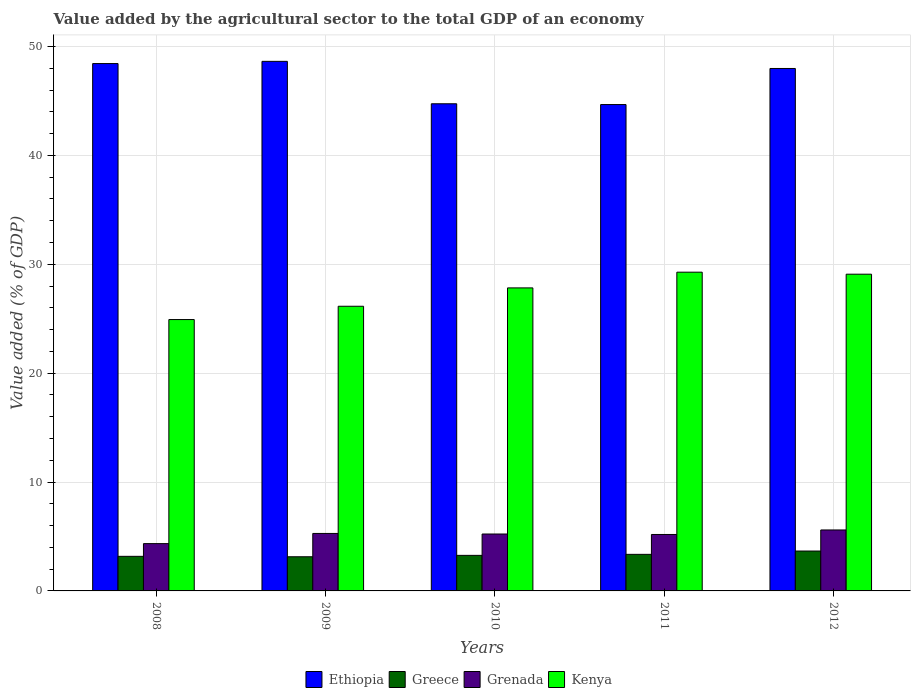How many bars are there on the 3rd tick from the left?
Provide a short and direct response. 4. How many bars are there on the 2nd tick from the right?
Keep it short and to the point. 4. What is the value added by the agricultural sector to the total GDP in Grenada in 2010?
Offer a terse response. 5.23. Across all years, what is the maximum value added by the agricultural sector to the total GDP in Greece?
Your answer should be compact. 3.66. Across all years, what is the minimum value added by the agricultural sector to the total GDP in Grenada?
Provide a succinct answer. 4.34. What is the total value added by the agricultural sector to the total GDP in Grenada in the graph?
Offer a very short reply. 25.63. What is the difference between the value added by the agricultural sector to the total GDP in Greece in 2008 and that in 2010?
Offer a terse response. -0.09. What is the difference between the value added by the agricultural sector to the total GDP in Ethiopia in 2008 and the value added by the agricultural sector to the total GDP in Kenya in 2012?
Your answer should be very brief. 19.34. What is the average value added by the agricultural sector to the total GDP in Kenya per year?
Provide a succinct answer. 27.45. In the year 2011, what is the difference between the value added by the agricultural sector to the total GDP in Grenada and value added by the agricultural sector to the total GDP in Kenya?
Ensure brevity in your answer.  -24.09. What is the ratio of the value added by the agricultural sector to the total GDP in Grenada in 2010 to that in 2011?
Offer a terse response. 1.01. Is the value added by the agricultural sector to the total GDP in Ethiopia in 2009 less than that in 2011?
Give a very brief answer. No. Is the difference between the value added by the agricultural sector to the total GDP in Grenada in 2009 and 2012 greater than the difference between the value added by the agricultural sector to the total GDP in Kenya in 2009 and 2012?
Keep it short and to the point. Yes. What is the difference between the highest and the second highest value added by the agricultural sector to the total GDP in Kenya?
Offer a very short reply. 0.18. What is the difference between the highest and the lowest value added by the agricultural sector to the total GDP in Ethiopia?
Make the answer very short. 3.97. Is the sum of the value added by the agricultural sector to the total GDP in Kenya in 2011 and 2012 greater than the maximum value added by the agricultural sector to the total GDP in Greece across all years?
Keep it short and to the point. Yes. What does the 1st bar from the left in 2012 represents?
Provide a succinct answer. Ethiopia. What does the 3rd bar from the right in 2012 represents?
Make the answer very short. Greece. Is it the case that in every year, the sum of the value added by the agricultural sector to the total GDP in Grenada and value added by the agricultural sector to the total GDP in Greece is greater than the value added by the agricultural sector to the total GDP in Ethiopia?
Give a very brief answer. No. What is the difference between two consecutive major ticks on the Y-axis?
Provide a succinct answer. 10. Are the values on the major ticks of Y-axis written in scientific E-notation?
Provide a succinct answer. No. Does the graph contain any zero values?
Offer a terse response. No. Where does the legend appear in the graph?
Your answer should be compact. Bottom center. How many legend labels are there?
Keep it short and to the point. 4. How are the legend labels stacked?
Provide a succinct answer. Horizontal. What is the title of the graph?
Offer a terse response. Value added by the agricultural sector to the total GDP of an economy. Does "Gabon" appear as one of the legend labels in the graph?
Provide a short and direct response. No. What is the label or title of the Y-axis?
Your answer should be very brief. Value added (% of GDP). What is the Value added (% of GDP) in Ethiopia in 2008?
Provide a succinct answer. 48.43. What is the Value added (% of GDP) in Greece in 2008?
Provide a succinct answer. 3.18. What is the Value added (% of GDP) of Grenada in 2008?
Make the answer very short. 4.34. What is the Value added (% of GDP) in Kenya in 2008?
Offer a very short reply. 24.92. What is the Value added (% of GDP) of Ethiopia in 2009?
Provide a short and direct response. 48.64. What is the Value added (% of GDP) in Greece in 2009?
Make the answer very short. 3.14. What is the Value added (% of GDP) of Grenada in 2009?
Provide a short and direct response. 5.28. What is the Value added (% of GDP) in Kenya in 2009?
Your answer should be very brief. 26.14. What is the Value added (% of GDP) of Ethiopia in 2010?
Your answer should be compact. 44.74. What is the Value added (% of GDP) in Greece in 2010?
Your answer should be very brief. 3.27. What is the Value added (% of GDP) of Grenada in 2010?
Offer a very short reply. 5.23. What is the Value added (% of GDP) in Kenya in 2010?
Your answer should be compact. 27.83. What is the Value added (% of GDP) of Ethiopia in 2011?
Your response must be concise. 44.67. What is the Value added (% of GDP) in Greece in 2011?
Offer a very short reply. 3.36. What is the Value added (% of GDP) in Grenada in 2011?
Make the answer very short. 5.18. What is the Value added (% of GDP) of Kenya in 2011?
Offer a very short reply. 29.27. What is the Value added (% of GDP) in Ethiopia in 2012?
Your response must be concise. 47.98. What is the Value added (% of GDP) in Greece in 2012?
Give a very brief answer. 3.66. What is the Value added (% of GDP) of Grenada in 2012?
Provide a succinct answer. 5.6. What is the Value added (% of GDP) in Kenya in 2012?
Your answer should be compact. 29.09. Across all years, what is the maximum Value added (% of GDP) in Ethiopia?
Make the answer very short. 48.64. Across all years, what is the maximum Value added (% of GDP) in Greece?
Give a very brief answer. 3.66. Across all years, what is the maximum Value added (% of GDP) of Grenada?
Offer a very short reply. 5.6. Across all years, what is the maximum Value added (% of GDP) of Kenya?
Provide a short and direct response. 29.27. Across all years, what is the minimum Value added (% of GDP) of Ethiopia?
Your answer should be compact. 44.67. Across all years, what is the minimum Value added (% of GDP) of Greece?
Keep it short and to the point. 3.14. Across all years, what is the minimum Value added (% of GDP) of Grenada?
Make the answer very short. 4.34. Across all years, what is the minimum Value added (% of GDP) of Kenya?
Your answer should be compact. 24.92. What is the total Value added (% of GDP) in Ethiopia in the graph?
Your answer should be compact. 234.46. What is the total Value added (% of GDP) in Greece in the graph?
Your answer should be very brief. 16.6. What is the total Value added (% of GDP) of Grenada in the graph?
Provide a succinct answer. 25.63. What is the total Value added (% of GDP) of Kenya in the graph?
Make the answer very short. 137.26. What is the difference between the Value added (% of GDP) of Ethiopia in 2008 and that in 2009?
Your response must be concise. -0.2. What is the difference between the Value added (% of GDP) in Greece in 2008 and that in 2009?
Your answer should be very brief. 0.04. What is the difference between the Value added (% of GDP) in Grenada in 2008 and that in 2009?
Your response must be concise. -0.94. What is the difference between the Value added (% of GDP) of Kenya in 2008 and that in 2009?
Make the answer very short. -1.22. What is the difference between the Value added (% of GDP) in Ethiopia in 2008 and that in 2010?
Ensure brevity in your answer.  3.69. What is the difference between the Value added (% of GDP) of Greece in 2008 and that in 2010?
Make the answer very short. -0.09. What is the difference between the Value added (% of GDP) of Grenada in 2008 and that in 2010?
Make the answer very short. -0.88. What is the difference between the Value added (% of GDP) of Kenya in 2008 and that in 2010?
Provide a short and direct response. -2.91. What is the difference between the Value added (% of GDP) in Ethiopia in 2008 and that in 2011?
Offer a terse response. 3.76. What is the difference between the Value added (% of GDP) in Greece in 2008 and that in 2011?
Your answer should be very brief. -0.18. What is the difference between the Value added (% of GDP) in Grenada in 2008 and that in 2011?
Provide a short and direct response. -0.84. What is the difference between the Value added (% of GDP) of Kenya in 2008 and that in 2011?
Provide a succinct answer. -4.35. What is the difference between the Value added (% of GDP) in Ethiopia in 2008 and that in 2012?
Provide a succinct answer. 0.45. What is the difference between the Value added (% of GDP) of Greece in 2008 and that in 2012?
Give a very brief answer. -0.49. What is the difference between the Value added (% of GDP) of Grenada in 2008 and that in 2012?
Provide a short and direct response. -1.25. What is the difference between the Value added (% of GDP) in Kenya in 2008 and that in 2012?
Your answer should be very brief. -4.17. What is the difference between the Value added (% of GDP) of Ethiopia in 2009 and that in 2010?
Offer a very short reply. 3.9. What is the difference between the Value added (% of GDP) in Greece in 2009 and that in 2010?
Make the answer very short. -0.13. What is the difference between the Value added (% of GDP) of Grenada in 2009 and that in 2010?
Provide a succinct answer. 0.05. What is the difference between the Value added (% of GDP) of Kenya in 2009 and that in 2010?
Offer a very short reply. -1.69. What is the difference between the Value added (% of GDP) of Ethiopia in 2009 and that in 2011?
Your response must be concise. 3.97. What is the difference between the Value added (% of GDP) in Greece in 2009 and that in 2011?
Make the answer very short. -0.22. What is the difference between the Value added (% of GDP) in Grenada in 2009 and that in 2011?
Ensure brevity in your answer.  0.1. What is the difference between the Value added (% of GDP) in Kenya in 2009 and that in 2011?
Make the answer very short. -3.13. What is the difference between the Value added (% of GDP) in Ethiopia in 2009 and that in 2012?
Your response must be concise. 0.65. What is the difference between the Value added (% of GDP) of Greece in 2009 and that in 2012?
Your response must be concise. -0.53. What is the difference between the Value added (% of GDP) in Grenada in 2009 and that in 2012?
Your answer should be very brief. -0.32. What is the difference between the Value added (% of GDP) in Kenya in 2009 and that in 2012?
Your answer should be compact. -2.95. What is the difference between the Value added (% of GDP) of Ethiopia in 2010 and that in 2011?
Provide a short and direct response. 0.07. What is the difference between the Value added (% of GDP) in Greece in 2010 and that in 2011?
Offer a terse response. -0.09. What is the difference between the Value added (% of GDP) of Grenada in 2010 and that in 2011?
Offer a very short reply. 0.04. What is the difference between the Value added (% of GDP) of Kenya in 2010 and that in 2011?
Ensure brevity in your answer.  -1.44. What is the difference between the Value added (% of GDP) of Ethiopia in 2010 and that in 2012?
Offer a very short reply. -3.24. What is the difference between the Value added (% of GDP) in Greece in 2010 and that in 2012?
Offer a terse response. -0.4. What is the difference between the Value added (% of GDP) of Grenada in 2010 and that in 2012?
Provide a succinct answer. -0.37. What is the difference between the Value added (% of GDP) in Kenya in 2010 and that in 2012?
Provide a succinct answer. -1.26. What is the difference between the Value added (% of GDP) in Ethiopia in 2011 and that in 2012?
Your response must be concise. -3.31. What is the difference between the Value added (% of GDP) of Greece in 2011 and that in 2012?
Provide a succinct answer. -0.31. What is the difference between the Value added (% of GDP) of Grenada in 2011 and that in 2012?
Your answer should be very brief. -0.42. What is the difference between the Value added (% of GDP) in Kenya in 2011 and that in 2012?
Your answer should be compact. 0.18. What is the difference between the Value added (% of GDP) in Ethiopia in 2008 and the Value added (% of GDP) in Greece in 2009?
Keep it short and to the point. 45.3. What is the difference between the Value added (% of GDP) in Ethiopia in 2008 and the Value added (% of GDP) in Grenada in 2009?
Offer a terse response. 43.15. What is the difference between the Value added (% of GDP) in Ethiopia in 2008 and the Value added (% of GDP) in Kenya in 2009?
Provide a short and direct response. 22.29. What is the difference between the Value added (% of GDP) of Greece in 2008 and the Value added (% of GDP) of Grenada in 2009?
Your answer should be very brief. -2.1. What is the difference between the Value added (% of GDP) in Greece in 2008 and the Value added (% of GDP) in Kenya in 2009?
Offer a very short reply. -22.97. What is the difference between the Value added (% of GDP) of Grenada in 2008 and the Value added (% of GDP) of Kenya in 2009?
Give a very brief answer. -21.8. What is the difference between the Value added (% of GDP) of Ethiopia in 2008 and the Value added (% of GDP) of Greece in 2010?
Offer a very short reply. 45.17. What is the difference between the Value added (% of GDP) of Ethiopia in 2008 and the Value added (% of GDP) of Grenada in 2010?
Make the answer very short. 43.21. What is the difference between the Value added (% of GDP) of Ethiopia in 2008 and the Value added (% of GDP) of Kenya in 2010?
Offer a very short reply. 20.6. What is the difference between the Value added (% of GDP) of Greece in 2008 and the Value added (% of GDP) of Grenada in 2010?
Offer a very short reply. -2.05. What is the difference between the Value added (% of GDP) in Greece in 2008 and the Value added (% of GDP) in Kenya in 2010?
Make the answer very short. -24.65. What is the difference between the Value added (% of GDP) of Grenada in 2008 and the Value added (% of GDP) of Kenya in 2010?
Your response must be concise. -23.49. What is the difference between the Value added (% of GDP) in Ethiopia in 2008 and the Value added (% of GDP) in Greece in 2011?
Provide a succinct answer. 45.08. What is the difference between the Value added (% of GDP) in Ethiopia in 2008 and the Value added (% of GDP) in Grenada in 2011?
Keep it short and to the point. 43.25. What is the difference between the Value added (% of GDP) in Ethiopia in 2008 and the Value added (% of GDP) in Kenya in 2011?
Give a very brief answer. 19.16. What is the difference between the Value added (% of GDP) of Greece in 2008 and the Value added (% of GDP) of Grenada in 2011?
Your answer should be compact. -2.01. What is the difference between the Value added (% of GDP) of Greece in 2008 and the Value added (% of GDP) of Kenya in 2011?
Give a very brief answer. -26.1. What is the difference between the Value added (% of GDP) in Grenada in 2008 and the Value added (% of GDP) in Kenya in 2011?
Make the answer very short. -24.93. What is the difference between the Value added (% of GDP) in Ethiopia in 2008 and the Value added (% of GDP) in Greece in 2012?
Your answer should be compact. 44.77. What is the difference between the Value added (% of GDP) of Ethiopia in 2008 and the Value added (% of GDP) of Grenada in 2012?
Your answer should be compact. 42.83. What is the difference between the Value added (% of GDP) in Ethiopia in 2008 and the Value added (% of GDP) in Kenya in 2012?
Ensure brevity in your answer.  19.34. What is the difference between the Value added (% of GDP) in Greece in 2008 and the Value added (% of GDP) in Grenada in 2012?
Make the answer very short. -2.42. What is the difference between the Value added (% of GDP) of Greece in 2008 and the Value added (% of GDP) of Kenya in 2012?
Your response must be concise. -25.91. What is the difference between the Value added (% of GDP) of Grenada in 2008 and the Value added (% of GDP) of Kenya in 2012?
Your response must be concise. -24.75. What is the difference between the Value added (% of GDP) in Ethiopia in 2009 and the Value added (% of GDP) in Greece in 2010?
Provide a short and direct response. 45.37. What is the difference between the Value added (% of GDP) in Ethiopia in 2009 and the Value added (% of GDP) in Grenada in 2010?
Make the answer very short. 43.41. What is the difference between the Value added (% of GDP) in Ethiopia in 2009 and the Value added (% of GDP) in Kenya in 2010?
Make the answer very short. 20.81. What is the difference between the Value added (% of GDP) of Greece in 2009 and the Value added (% of GDP) of Grenada in 2010?
Make the answer very short. -2.09. What is the difference between the Value added (% of GDP) of Greece in 2009 and the Value added (% of GDP) of Kenya in 2010?
Offer a terse response. -24.69. What is the difference between the Value added (% of GDP) of Grenada in 2009 and the Value added (% of GDP) of Kenya in 2010?
Provide a short and direct response. -22.55. What is the difference between the Value added (% of GDP) of Ethiopia in 2009 and the Value added (% of GDP) of Greece in 2011?
Keep it short and to the point. 45.28. What is the difference between the Value added (% of GDP) of Ethiopia in 2009 and the Value added (% of GDP) of Grenada in 2011?
Your answer should be very brief. 43.45. What is the difference between the Value added (% of GDP) of Ethiopia in 2009 and the Value added (% of GDP) of Kenya in 2011?
Keep it short and to the point. 19.36. What is the difference between the Value added (% of GDP) in Greece in 2009 and the Value added (% of GDP) in Grenada in 2011?
Provide a succinct answer. -2.05. What is the difference between the Value added (% of GDP) in Greece in 2009 and the Value added (% of GDP) in Kenya in 2011?
Your response must be concise. -26.14. What is the difference between the Value added (% of GDP) of Grenada in 2009 and the Value added (% of GDP) of Kenya in 2011?
Your answer should be compact. -23.99. What is the difference between the Value added (% of GDP) of Ethiopia in 2009 and the Value added (% of GDP) of Greece in 2012?
Offer a very short reply. 44.97. What is the difference between the Value added (% of GDP) in Ethiopia in 2009 and the Value added (% of GDP) in Grenada in 2012?
Provide a succinct answer. 43.04. What is the difference between the Value added (% of GDP) of Ethiopia in 2009 and the Value added (% of GDP) of Kenya in 2012?
Give a very brief answer. 19.55. What is the difference between the Value added (% of GDP) of Greece in 2009 and the Value added (% of GDP) of Grenada in 2012?
Provide a short and direct response. -2.46. What is the difference between the Value added (% of GDP) in Greece in 2009 and the Value added (% of GDP) in Kenya in 2012?
Offer a terse response. -25.95. What is the difference between the Value added (% of GDP) of Grenada in 2009 and the Value added (% of GDP) of Kenya in 2012?
Keep it short and to the point. -23.81. What is the difference between the Value added (% of GDP) in Ethiopia in 2010 and the Value added (% of GDP) in Greece in 2011?
Keep it short and to the point. 41.38. What is the difference between the Value added (% of GDP) of Ethiopia in 2010 and the Value added (% of GDP) of Grenada in 2011?
Offer a very short reply. 39.56. What is the difference between the Value added (% of GDP) of Ethiopia in 2010 and the Value added (% of GDP) of Kenya in 2011?
Ensure brevity in your answer.  15.47. What is the difference between the Value added (% of GDP) in Greece in 2010 and the Value added (% of GDP) in Grenada in 2011?
Your answer should be very brief. -1.92. What is the difference between the Value added (% of GDP) of Greece in 2010 and the Value added (% of GDP) of Kenya in 2011?
Make the answer very short. -26.01. What is the difference between the Value added (% of GDP) of Grenada in 2010 and the Value added (% of GDP) of Kenya in 2011?
Make the answer very short. -24.05. What is the difference between the Value added (% of GDP) of Ethiopia in 2010 and the Value added (% of GDP) of Greece in 2012?
Make the answer very short. 41.08. What is the difference between the Value added (% of GDP) of Ethiopia in 2010 and the Value added (% of GDP) of Grenada in 2012?
Make the answer very short. 39.14. What is the difference between the Value added (% of GDP) in Ethiopia in 2010 and the Value added (% of GDP) in Kenya in 2012?
Your answer should be very brief. 15.65. What is the difference between the Value added (% of GDP) in Greece in 2010 and the Value added (% of GDP) in Grenada in 2012?
Offer a very short reply. -2.33. What is the difference between the Value added (% of GDP) of Greece in 2010 and the Value added (% of GDP) of Kenya in 2012?
Ensure brevity in your answer.  -25.82. What is the difference between the Value added (% of GDP) in Grenada in 2010 and the Value added (% of GDP) in Kenya in 2012?
Provide a succinct answer. -23.86. What is the difference between the Value added (% of GDP) of Ethiopia in 2011 and the Value added (% of GDP) of Greece in 2012?
Your answer should be very brief. 41.01. What is the difference between the Value added (% of GDP) in Ethiopia in 2011 and the Value added (% of GDP) in Grenada in 2012?
Give a very brief answer. 39.07. What is the difference between the Value added (% of GDP) in Ethiopia in 2011 and the Value added (% of GDP) in Kenya in 2012?
Ensure brevity in your answer.  15.58. What is the difference between the Value added (% of GDP) of Greece in 2011 and the Value added (% of GDP) of Grenada in 2012?
Ensure brevity in your answer.  -2.24. What is the difference between the Value added (% of GDP) of Greece in 2011 and the Value added (% of GDP) of Kenya in 2012?
Ensure brevity in your answer.  -25.73. What is the difference between the Value added (% of GDP) in Grenada in 2011 and the Value added (% of GDP) in Kenya in 2012?
Provide a succinct answer. -23.91. What is the average Value added (% of GDP) of Ethiopia per year?
Provide a succinct answer. 46.89. What is the average Value added (% of GDP) in Greece per year?
Ensure brevity in your answer.  3.32. What is the average Value added (% of GDP) of Grenada per year?
Make the answer very short. 5.13. What is the average Value added (% of GDP) of Kenya per year?
Provide a short and direct response. 27.45. In the year 2008, what is the difference between the Value added (% of GDP) in Ethiopia and Value added (% of GDP) in Greece?
Keep it short and to the point. 45.26. In the year 2008, what is the difference between the Value added (% of GDP) of Ethiopia and Value added (% of GDP) of Grenada?
Offer a very short reply. 44.09. In the year 2008, what is the difference between the Value added (% of GDP) of Ethiopia and Value added (% of GDP) of Kenya?
Ensure brevity in your answer.  23.51. In the year 2008, what is the difference between the Value added (% of GDP) in Greece and Value added (% of GDP) in Grenada?
Offer a very short reply. -1.17. In the year 2008, what is the difference between the Value added (% of GDP) in Greece and Value added (% of GDP) in Kenya?
Your response must be concise. -21.75. In the year 2008, what is the difference between the Value added (% of GDP) in Grenada and Value added (% of GDP) in Kenya?
Your response must be concise. -20.58. In the year 2009, what is the difference between the Value added (% of GDP) of Ethiopia and Value added (% of GDP) of Greece?
Keep it short and to the point. 45.5. In the year 2009, what is the difference between the Value added (% of GDP) of Ethiopia and Value added (% of GDP) of Grenada?
Your answer should be very brief. 43.36. In the year 2009, what is the difference between the Value added (% of GDP) of Ethiopia and Value added (% of GDP) of Kenya?
Ensure brevity in your answer.  22.49. In the year 2009, what is the difference between the Value added (% of GDP) in Greece and Value added (% of GDP) in Grenada?
Ensure brevity in your answer.  -2.14. In the year 2009, what is the difference between the Value added (% of GDP) of Greece and Value added (% of GDP) of Kenya?
Your response must be concise. -23.01. In the year 2009, what is the difference between the Value added (% of GDP) of Grenada and Value added (% of GDP) of Kenya?
Make the answer very short. -20.86. In the year 2010, what is the difference between the Value added (% of GDP) of Ethiopia and Value added (% of GDP) of Greece?
Your response must be concise. 41.48. In the year 2010, what is the difference between the Value added (% of GDP) in Ethiopia and Value added (% of GDP) in Grenada?
Your answer should be compact. 39.51. In the year 2010, what is the difference between the Value added (% of GDP) of Ethiopia and Value added (% of GDP) of Kenya?
Offer a terse response. 16.91. In the year 2010, what is the difference between the Value added (% of GDP) in Greece and Value added (% of GDP) in Grenada?
Keep it short and to the point. -1.96. In the year 2010, what is the difference between the Value added (% of GDP) of Greece and Value added (% of GDP) of Kenya?
Keep it short and to the point. -24.57. In the year 2010, what is the difference between the Value added (% of GDP) of Grenada and Value added (% of GDP) of Kenya?
Give a very brief answer. -22.6. In the year 2011, what is the difference between the Value added (% of GDP) of Ethiopia and Value added (% of GDP) of Greece?
Provide a short and direct response. 41.31. In the year 2011, what is the difference between the Value added (% of GDP) in Ethiopia and Value added (% of GDP) in Grenada?
Offer a very short reply. 39.49. In the year 2011, what is the difference between the Value added (% of GDP) in Ethiopia and Value added (% of GDP) in Kenya?
Your answer should be very brief. 15.4. In the year 2011, what is the difference between the Value added (% of GDP) in Greece and Value added (% of GDP) in Grenada?
Offer a very short reply. -1.83. In the year 2011, what is the difference between the Value added (% of GDP) of Greece and Value added (% of GDP) of Kenya?
Offer a very short reply. -25.92. In the year 2011, what is the difference between the Value added (% of GDP) in Grenada and Value added (% of GDP) in Kenya?
Your answer should be compact. -24.09. In the year 2012, what is the difference between the Value added (% of GDP) in Ethiopia and Value added (% of GDP) in Greece?
Offer a very short reply. 44.32. In the year 2012, what is the difference between the Value added (% of GDP) of Ethiopia and Value added (% of GDP) of Grenada?
Offer a terse response. 42.38. In the year 2012, what is the difference between the Value added (% of GDP) of Ethiopia and Value added (% of GDP) of Kenya?
Keep it short and to the point. 18.89. In the year 2012, what is the difference between the Value added (% of GDP) in Greece and Value added (% of GDP) in Grenada?
Your answer should be compact. -1.94. In the year 2012, what is the difference between the Value added (% of GDP) of Greece and Value added (% of GDP) of Kenya?
Offer a terse response. -25.43. In the year 2012, what is the difference between the Value added (% of GDP) of Grenada and Value added (% of GDP) of Kenya?
Give a very brief answer. -23.49. What is the ratio of the Value added (% of GDP) of Greece in 2008 to that in 2009?
Make the answer very short. 1.01. What is the ratio of the Value added (% of GDP) in Grenada in 2008 to that in 2009?
Make the answer very short. 0.82. What is the ratio of the Value added (% of GDP) in Kenya in 2008 to that in 2009?
Give a very brief answer. 0.95. What is the ratio of the Value added (% of GDP) of Ethiopia in 2008 to that in 2010?
Provide a succinct answer. 1.08. What is the ratio of the Value added (% of GDP) of Greece in 2008 to that in 2010?
Offer a terse response. 0.97. What is the ratio of the Value added (% of GDP) of Grenada in 2008 to that in 2010?
Your answer should be compact. 0.83. What is the ratio of the Value added (% of GDP) in Kenya in 2008 to that in 2010?
Your response must be concise. 0.9. What is the ratio of the Value added (% of GDP) in Ethiopia in 2008 to that in 2011?
Offer a very short reply. 1.08. What is the ratio of the Value added (% of GDP) in Greece in 2008 to that in 2011?
Your answer should be compact. 0.95. What is the ratio of the Value added (% of GDP) of Grenada in 2008 to that in 2011?
Offer a very short reply. 0.84. What is the ratio of the Value added (% of GDP) in Kenya in 2008 to that in 2011?
Keep it short and to the point. 0.85. What is the ratio of the Value added (% of GDP) in Ethiopia in 2008 to that in 2012?
Provide a short and direct response. 1.01. What is the ratio of the Value added (% of GDP) in Greece in 2008 to that in 2012?
Offer a very short reply. 0.87. What is the ratio of the Value added (% of GDP) of Grenada in 2008 to that in 2012?
Ensure brevity in your answer.  0.78. What is the ratio of the Value added (% of GDP) of Kenya in 2008 to that in 2012?
Ensure brevity in your answer.  0.86. What is the ratio of the Value added (% of GDP) in Ethiopia in 2009 to that in 2010?
Your answer should be very brief. 1.09. What is the ratio of the Value added (% of GDP) in Greece in 2009 to that in 2010?
Ensure brevity in your answer.  0.96. What is the ratio of the Value added (% of GDP) in Grenada in 2009 to that in 2010?
Offer a terse response. 1.01. What is the ratio of the Value added (% of GDP) in Kenya in 2009 to that in 2010?
Provide a succinct answer. 0.94. What is the ratio of the Value added (% of GDP) in Ethiopia in 2009 to that in 2011?
Provide a short and direct response. 1.09. What is the ratio of the Value added (% of GDP) of Greece in 2009 to that in 2011?
Offer a very short reply. 0.93. What is the ratio of the Value added (% of GDP) of Grenada in 2009 to that in 2011?
Offer a very short reply. 1.02. What is the ratio of the Value added (% of GDP) in Kenya in 2009 to that in 2011?
Provide a short and direct response. 0.89. What is the ratio of the Value added (% of GDP) in Ethiopia in 2009 to that in 2012?
Ensure brevity in your answer.  1.01. What is the ratio of the Value added (% of GDP) in Greece in 2009 to that in 2012?
Offer a very short reply. 0.86. What is the ratio of the Value added (% of GDP) of Grenada in 2009 to that in 2012?
Your answer should be compact. 0.94. What is the ratio of the Value added (% of GDP) in Kenya in 2009 to that in 2012?
Provide a succinct answer. 0.9. What is the ratio of the Value added (% of GDP) of Greece in 2010 to that in 2011?
Your answer should be very brief. 0.97. What is the ratio of the Value added (% of GDP) of Grenada in 2010 to that in 2011?
Provide a short and direct response. 1.01. What is the ratio of the Value added (% of GDP) in Kenya in 2010 to that in 2011?
Your response must be concise. 0.95. What is the ratio of the Value added (% of GDP) in Ethiopia in 2010 to that in 2012?
Your answer should be very brief. 0.93. What is the ratio of the Value added (% of GDP) in Greece in 2010 to that in 2012?
Keep it short and to the point. 0.89. What is the ratio of the Value added (% of GDP) in Grenada in 2010 to that in 2012?
Your answer should be very brief. 0.93. What is the ratio of the Value added (% of GDP) of Kenya in 2010 to that in 2012?
Give a very brief answer. 0.96. What is the ratio of the Value added (% of GDP) in Ethiopia in 2011 to that in 2012?
Provide a succinct answer. 0.93. What is the ratio of the Value added (% of GDP) in Greece in 2011 to that in 2012?
Ensure brevity in your answer.  0.92. What is the ratio of the Value added (% of GDP) in Grenada in 2011 to that in 2012?
Ensure brevity in your answer.  0.93. What is the ratio of the Value added (% of GDP) in Kenya in 2011 to that in 2012?
Your answer should be very brief. 1.01. What is the difference between the highest and the second highest Value added (% of GDP) in Ethiopia?
Provide a succinct answer. 0.2. What is the difference between the highest and the second highest Value added (% of GDP) in Greece?
Your response must be concise. 0.31. What is the difference between the highest and the second highest Value added (% of GDP) of Grenada?
Make the answer very short. 0.32. What is the difference between the highest and the second highest Value added (% of GDP) in Kenya?
Offer a very short reply. 0.18. What is the difference between the highest and the lowest Value added (% of GDP) in Ethiopia?
Give a very brief answer. 3.97. What is the difference between the highest and the lowest Value added (% of GDP) in Greece?
Provide a short and direct response. 0.53. What is the difference between the highest and the lowest Value added (% of GDP) of Grenada?
Provide a short and direct response. 1.25. What is the difference between the highest and the lowest Value added (% of GDP) of Kenya?
Offer a very short reply. 4.35. 